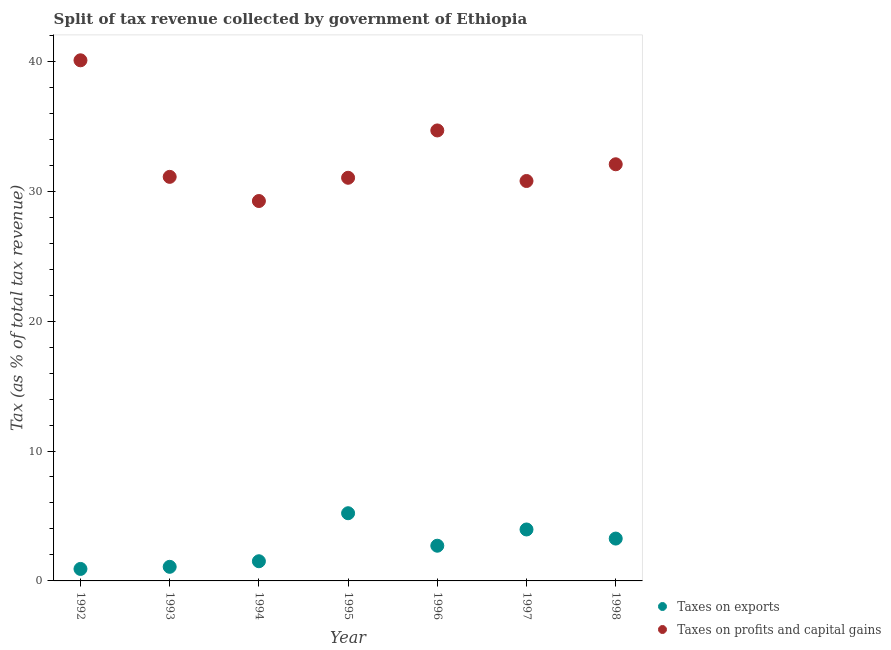What is the percentage of revenue obtained from taxes on exports in 1992?
Offer a very short reply. 0.92. Across all years, what is the maximum percentage of revenue obtained from taxes on profits and capital gains?
Your response must be concise. 40.07. Across all years, what is the minimum percentage of revenue obtained from taxes on exports?
Give a very brief answer. 0.92. What is the total percentage of revenue obtained from taxes on profits and capital gains in the graph?
Give a very brief answer. 228.97. What is the difference between the percentage of revenue obtained from taxes on exports in 1996 and that in 1998?
Offer a terse response. -0.55. What is the difference between the percentage of revenue obtained from taxes on exports in 1997 and the percentage of revenue obtained from taxes on profits and capital gains in 1995?
Your answer should be very brief. -27.07. What is the average percentage of revenue obtained from taxes on exports per year?
Make the answer very short. 2.67. In the year 1998, what is the difference between the percentage of revenue obtained from taxes on exports and percentage of revenue obtained from taxes on profits and capital gains?
Ensure brevity in your answer.  -28.81. In how many years, is the percentage of revenue obtained from taxes on profits and capital gains greater than 8 %?
Offer a very short reply. 7. What is the ratio of the percentage of revenue obtained from taxes on profits and capital gains in 1993 to that in 1997?
Offer a terse response. 1.01. Is the percentage of revenue obtained from taxes on exports in 1994 less than that in 1996?
Ensure brevity in your answer.  Yes. Is the difference between the percentage of revenue obtained from taxes on profits and capital gains in 1996 and 1997 greater than the difference between the percentage of revenue obtained from taxes on exports in 1996 and 1997?
Offer a very short reply. Yes. What is the difference between the highest and the second highest percentage of revenue obtained from taxes on profits and capital gains?
Provide a succinct answer. 5.4. What is the difference between the highest and the lowest percentage of revenue obtained from taxes on profits and capital gains?
Make the answer very short. 10.83. Does the percentage of revenue obtained from taxes on profits and capital gains monotonically increase over the years?
Your response must be concise. No. What is the difference between two consecutive major ticks on the Y-axis?
Provide a succinct answer. 10. Are the values on the major ticks of Y-axis written in scientific E-notation?
Your answer should be compact. No. Where does the legend appear in the graph?
Give a very brief answer. Bottom right. How are the legend labels stacked?
Your answer should be very brief. Vertical. What is the title of the graph?
Your answer should be very brief. Split of tax revenue collected by government of Ethiopia. What is the label or title of the X-axis?
Give a very brief answer. Year. What is the label or title of the Y-axis?
Your answer should be very brief. Tax (as % of total tax revenue). What is the Tax (as % of total tax revenue) in Taxes on exports in 1992?
Keep it short and to the point. 0.92. What is the Tax (as % of total tax revenue) of Taxes on profits and capital gains in 1992?
Offer a very short reply. 40.07. What is the Tax (as % of total tax revenue) of Taxes on exports in 1993?
Offer a very short reply. 1.09. What is the Tax (as % of total tax revenue) in Taxes on profits and capital gains in 1993?
Offer a very short reply. 31.1. What is the Tax (as % of total tax revenue) in Taxes on exports in 1994?
Provide a short and direct response. 1.51. What is the Tax (as % of total tax revenue) in Taxes on profits and capital gains in 1994?
Your answer should be compact. 29.24. What is the Tax (as % of total tax revenue) in Taxes on exports in 1995?
Your response must be concise. 5.21. What is the Tax (as % of total tax revenue) in Taxes on profits and capital gains in 1995?
Provide a short and direct response. 31.03. What is the Tax (as % of total tax revenue) of Taxes on exports in 1996?
Keep it short and to the point. 2.71. What is the Tax (as % of total tax revenue) of Taxes on profits and capital gains in 1996?
Provide a short and direct response. 34.67. What is the Tax (as % of total tax revenue) in Taxes on exports in 1997?
Your response must be concise. 3.96. What is the Tax (as % of total tax revenue) of Taxes on profits and capital gains in 1997?
Provide a succinct answer. 30.78. What is the Tax (as % of total tax revenue) of Taxes on exports in 1998?
Offer a very short reply. 3.26. What is the Tax (as % of total tax revenue) in Taxes on profits and capital gains in 1998?
Give a very brief answer. 32.07. Across all years, what is the maximum Tax (as % of total tax revenue) in Taxes on exports?
Your response must be concise. 5.21. Across all years, what is the maximum Tax (as % of total tax revenue) in Taxes on profits and capital gains?
Your answer should be compact. 40.07. Across all years, what is the minimum Tax (as % of total tax revenue) of Taxes on exports?
Ensure brevity in your answer.  0.92. Across all years, what is the minimum Tax (as % of total tax revenue) of Taxes on profits and capital gains?
Offer a very short reply. 29.24. What is the total Tax (as % of total tax revenue) in Taxes on exports in the graph?
Your response must be concise. 18.66. What is the total Tax (as % of total tax revenue) of Taxes on profits and capital gains in the graph?
Give a very brief answer. 228.97. What is the difference between the Tax (as % of total tax revenue) of Taxes on exports in 1992 and that in 1993?
Provide a short and direct response. -0.16. What is the difference between the Tax (as % of total tax revenue) in Taxes on profits and capital gains in 1992 and that in 1993?
Provide a short and direct response. 8.97. What is the difference between the Tax (as % of total tax revenue) of Taxes on exports in 1992 and that in 1994?
Your answer should be compact. -0.59. What is the difference between the Tax (as % of total tax revenue) of Taxes on profits and capital gains in 1992 and that in 1994?
Ensure brevity in your answer.  10.83. What is the difference between the Tax (as % of total tax revenue) in Taxes on exports in 1992 and that in 1995?
Give a very brief answer. -4.29. What is the difference between the Tax (as % of total tax revenue) in Taxes on profits and capital gains in 1992 and that in 1995?
Give a very brief answer. 9.04. What is the difference between the Tax (as % of total tax revenue) in Taxes on exports in 1992 and that in 1996?
Provide a short and direct response. -1.79. What is the difference between the Tax (as % of total tax revenue) in Taxes on profits and capital gains in 1992 and that in 1996?
Your response must be concise. 5.4. What is the difference between the Tax (as % of total tax revenue) in Taxes on exports in 1992 and that in 1997?
Offer a very short reply. -3.04. What is the difference between the Tax (as % of total tax revenue) of Taxes on profits and capital gains in 1992 and that in 1997?
Ensure brevity in your answer.  9.29. What is the difference between the Tax (as % of total tax revenue) of Taxes on exports in 1992 and that in 1998?
Your answer should be compact. -2.34. What is the difference between the Tax (as % of total tax revenue) of Taxes on profits and capital gains in 1992 and that in 1998?
Your answer should be compact. 8. What is the difference between the Tax (as % of total tax revenue) of Taxes on exports in 1993 and that in 1994?
Make the answer very short. -0.43. What is the difference between the Tax (as % of total tax revenue) of Taxes on profits and capital gains in 1993 and that in 1994?
Give a very brief answer. 1.86. What is the difference between the Tax (as % of total tax revenue) of Taxes on exports in 1993 and that in 1995?
Your answer should be compact. -4.13. What is the difference between the Tax (as % of total tax revenue) in Taxes on profits and capital gains in 1993 and that in 1995?
Keep it short and to the point. 0.07. What is the difference between the Tax (as % of total tax revenue) in Taxes on exports in 1993 and that in 1996?
Provide a short and direct response. -1.62. What is the difference between the Tax (as % of total tax revenue) in Taxes on profits and capital gains in 1993 and that in 1996?
Ensure brevity in your answer.  -3.57. What is the difference between the Tax (as % of total tax revenue) in Taxes on exports in 1993 and that in 1997?
Make the answer very short. -2.88. What is the difference between the Tax (as % of total tax revenue) of Taxes on profits and capital gains in 1993 and that in 1997?
Give a very brief answer. 0.32. What is the difference between the Tax (as % of total tax revenue) in Taxes on exports in 1993 and that in 1998?
Your response must be concise. -2.17. What is the difference between the Tax (as % of total tax revenue) of Taxes on profits and capital gains in 1993 and that in 1998?
Offer a very short reply. -0.97. What is the difference between the Tax (as % of total tax revenue) of Taxes on exports in 1994 and that in 1995?
Offer a very short reply. -3.7. What is the difference between the Tax (as % of total tax revenue) in Taxes on profits and capital gains in 1994 and that in 1995?
Your response must be concise. -1.79. What is the difference between the Tax (as % of total tax revenue) in Taxes on exports in 1994 and that in 1996?
Keep it short and to the point. -1.19. What is the difference between the Tax (as % of total tax revenue) of Taxes on profits and capital gains in 1994 and that in 1996?
Offer a terse response. -5.43. What is the difference between the Tax (as % of total tax revenue) of Taxes on exports in 1994 and that in 1997?
Keep it short and to the point. -2.45. What is the difference between the Tax (as % of total tax revenue) in Taxes on profits and capital gains in 1994 and that in 1997?
Provide a short and direct response. -1.54. What is the difference between the Tax (as % of total tax revenue) of Taxes on exports in 1994 and that in 1998?
Provide a succinct answer. -1.74. What is the difference between the Tax (as % of total tax revenue) in Taxes on profits and capital gains in 1994 and that in 1998?
Ensure brevity in your answer.  -2.83. What is the difference between the Tax (as % of total tax revenue) of Taxes on exports in 1995 and that in 1996?
Your answer should be very brief. 2.5. What is the difference between the Tax (as % of total tax revenue) of Taxes on profits and capital gains in 1995 and that in 1996?
Provide a short and direct response. -3.64. What is the difference between the Tax (as % of total tax revenue) of Taxes on exports in 1995 and that in 1997?
Give a very brief answer. 1.25. What is the difference between the Tax (as % of total tax revenue) in Taxes on profits and capital gains in 1995 and that in 1997?
Your answer should be very brief. 0.25. What is the difference between the Tax (as % of total tax revenue) of Taxes on exports in 1995 and that in 1998?
Your answer should be very brief. 1.95. What is the difference between the Tax (as % of total tax revenue) in Taxes on profits and capital gains in 1995 and that in 1998?
Give a very brief answer. -1.04. What is the difference between the Tax (as % of total tax revenue) of Taxes on exports in 1996 and that in 1997?
Make the answer very short. -1.25. What is the difference between the Tax (as % of total tax revenue) of Taxes on profits and capital gains in 1996 and that in 1997?
Offer a very short reply. 3.89. What is the difference between the Tax (as % of total tax revenue) in Taxes on exports in 1996 and that in 1998?
Offer a terse response. -0.55. What is the difference between the Tax (as % of total tax revenue) of Taxes on profits and capital gains in 1996 and that in 1998?
Your answer should be compact. 2.6. What is the difference between the Tax (as % of total tax revenue) of Taxes on exports in 1997 and that in 1998?
Your answer should be compact. 0.7. What is the difference between the Tax (as % of total tax revenue) in Taxes on profits and capital gains in 1997 and that in 1998?
Your response must be concise. -1.29. What is the difference between the Tax (as % of total tax revenue) of Taxes on exports in 1992 and the Tax (as % of total tax revenue) of Taxes on profits and capital gains in 1993?
Make the answer very short. -30.18. What is the difference between the Tax (as % of total tax revenue) of Taxes on exports in 1992 and the Tax (as % of total tax revenue) of Taxes on profits and capital gains in 1994?
Offer a very short reply. -28.32. What is the difference between the Tax (as % of total tax revenue) of Taxes on exports in 1992 and the Tax (as % of total tax revenue) of Taxes on profits and capital gains in 1995?
Your response must be concise. -30.11. What is the difference between the Tax (as % of total tax revenue) of Taxes on exports in 1992 and the Tax (as % of total tax revenue) of Taxes on profits and capital gains in 1996?
Keep it short and to the point. -33.75. What is the difference between the Tax (as % of total tax revenue) in Taxes on exports in 1992 and the Tax (as % of total tax revenue) in Taxes on profits and capital gains in 1997?
Give a very brief answer. -29.86. What is the difference between the Tax (as % of total tax revenue) of Taxes on exports in 1992 and the Tax (as % of total tax revenue) of Taxes on profits and capital gains in 1998?
Provide a succinct answer. -31.15. What is the difference between the Tax (as % of total tax revenue) of Taxes on exports in 1993 and the Tax (as % of total tax revenue) of Taxes on profits and capital gains in 1994?
Your response must be concise. -28.16. What is the difference between the Tax (as % of total tax revenue) in Taxes on exports in 1993 and the Tax (as % of total tax revenue) in Taxes on profits and capital gains in 1995?
Offer a terse response. -29.95. What is the difference between the Tax (as % of total tax revenue) in Taxes on exports in 1993 and the Tax (as % of total tax revenue) in Taxes on profits and capital gains in 1996?
Provide a succinct answer. -33.59. What is the difference between the Tax (as % of total tax revenue) in Taxes on exports in 1993 and the Tax (as % of total tax revenue) in Taxes on profits and capital gains in 1997?
Provide a succinct answer. -29.7. What is the difference between the Tax (as % of total tax revenue) in Taxes on exports in 1993 and the Tax (as % of total tax revenue) in Taxes on profits and capital gains in 1998?
Ensure brevity in your answer.  -30.98. What is the difference between the Tax (as % of total tax revenue) in Taxes on exports in 1994 and the Tax (as % of total tax revenue) in Taxes on profits and capital gains in 1995?
Your response must be concise. -29.52. What is the difference between the Tax (as % of total tax revenue) of Taxes on exports in 1994 and the Tax (as % of total tax revenue) of Taxes on profits and capital gains in 1996?
Offer a terse response. -33.16. What is the difference between the Tax (as % of total tax revenue) of Taxes on exports in 1994 and the Tax (as % of total tax revenue) of Taxes on profits and capital gains in 1997?
Keep it short and to the point. -29.27. What is the difference between the Tax (as % of total tax revenue) in Taxes on exports in 1994 and the Tax (as % of total tax revenue) in Taxes on profits and capital gains in 1998?
Provide a short and direct response. -30.55. What is the difference between the Tax (as % of total tax revenue) in Taxes on exports in 1995 and the Tax (as % of total tax revenue) in Taxes on profits and capital gains in 1996?
Provide a short and direct response. -29.46. What is the difference between the Tax (as % of total tax revenue) of Taxes on exports in 1995 and the Tax (as % of total tax revenue) of Taxes on profits and capital gains in 1997?
Give a very brief answer. -25.57. What is the difference between the Tax (as % of total tax revenue) in Taxes on exports in 1995 and the Tax (as % of total tax revenue) in Taxes on profits and capital gains in 1998?
Keep it short and to the point. -26.86. What is the difference between the Tax (as % of total tax revenue) in Taxes on exports in 1996 and the Tax (as % of total tax revenue) in Taxes on profits and capital gains in 1997?
Your answer should be compact. -28.07. What is the difference between the Tax (as % of total tax revenue) in Taxes on exports in 1996 and the Tax (as % of total tax revenue) in Taxes on profits and capital gains in 1998?
Give a very brief answer. -29.36. What is the difference between the Tax (as % of total tax revenue) in Taxes on exports in 1997 and the Tax (as % of total tax revenue) in Taxes on profits and capital gains in 1998?
Make the answer very short. -28.11. What is the average Tax (as % of total tax revenue) of Taxes on exports per year?
Provide a succinct answer. 2.67. What is the average Tax (as % of total tax revenue) of Taxes on profits and capital gains per year?
Offer a very short reply. 32.71. In the year 1992, what is the difference between the Tax (as % of total tax revenue) in Taxes on exports and Tax (as % of total tax revenue) in Taxes on profits and capital gains?
Ensure brevity in your answer.  -39.15. In the year 1993, what is the difference between the Tax (as % of total tax revenue) in Taxes on exports and Tax (as % of total tax revenue) in Taxes on profits and capital gains?
Give a very brief answer. -30.02. In the year 1994, what is the difference between the Tax (as % of total tax revenue) of Taxes on exports and Tax (as % of total tax revenue) of Taxes on profits and capital gains?
Ensure brevity in your answer.  -27.73. In the year 1995, what is the difference between the Tax (as % of total tax revenue) in Taxes on exports and Tax (as % of total tax revenue) in Taxes on profits and capital gains?
Your answer should be compact. -25.82. In the year 1996, what is the difference between the Tax (as % of total tax revenue) of Taxes on exports and Tax (as % of total tax revenue) of Taxes on profits and capital gains?
Make the answer very short. -31.96. In the year 1997, what is the difference between the Tax (as % of total tax revenue) of Taxes on exports and Tax (as % of total tax revenue) of Taxes on profits and capital gains?
Offer a very short reply. -26.82. In the year 1998, what is the difference between the Tax (as % of total tax revenue) of Taxes on exports and Tax (as % of total tax revenue) of Taxes on profits and capital gains?
Make the answer very short. -28.81. What is the ratio of the Tax (as % of total tax revenue) in Taxes on exports in 1992 to that in 1993?
Give a very brief answer. 0.85. What is the ratio of the Tax (as % of total tax revenue) in Taxes on profits and capital gains in 1992 to that in 1993?
Make the answer very short. 1.29. What is the ratio of the Tax (as % of total tax revenue) of Taxes on exports in 1992 to that in 1994?
Provide a short and direct response. 0.61. What is the ratio of the Tax (as % of total tax revenue) of Taxes on profits and capital gains in 1992 to that in 1994?
Provide a short and direct response. 1.37. What is the ratio of the Tax (as % of total tax revenue) of Taxes on exports in 1992 to that in 1995?
Your answer should be very brief. 0.18. What is the ratio of the Tax (as % of total tax revenue) in Taxes on profits and capital gains in 1992 to that in 1995?
Provide a succinct answer. 1.29. What is the ratio of the Tax (as % of total tax revenue) of Taxes on exports in 1992 to that in 1996?
Your answer should be very brief. 0.34. What is the ratio of the Tax (as % of total tax revenue) of Taxes on profits and capital gains in 1992 to that in 1996?
Provide a short and direct response. 1.16. What is the ratio of the Tax (as % of total tax revenue) in Taxes on exports in 1992 to that in 1997?
Provide a succinct answer. 0.23. What is the ratio of the Tax (as % of total tax revenue) in Taxes on profits and capital gains in 1992 to that in 1997?
Make the answer very short. 1.3. What is the ratio of the Tax (as % of total tax revenue) in Taxes on exports in 1992 to that in 1998?
Your answer should be very brief. 0.28. What is the ratio of the Tax (as % of total tax revenue) of Taxes on profits and capital gains in 1992 to that in 1998?
Your answer should be very brief. 1.25. What is the ratio of the Tax (as % of total tax revenue) of Taxes on exports in 1993 to that in 1994?
Provide a short and direct response. 0.72. What is the ratio of the Tax (as % of total tax revenue) of Taxes on profits and capital gains in 1993 to that in 1994?
Offer a terse response. 1.06. What is the ratio of the Tax (as % of total tax revenue) in Taxes on exports in 1993 to that in 1995?
Make the answer very short. 0.21. What is the ratio of the Tax (as % of total tax revenue) in Taxes on exports in 1993 to that in 1996?
Provide a short and direct response. 0.4. What is the ratio of the Tax (as % of total tax revenue) in Taxes on profits and capital gains in 1993 to that in 1996?
Keep it short and to the point. 0.9. What is the ratio of the Tax (as % of total tax revenue) of Taxes on exports in 1993 to that in 1997?
Make the answer very short. 0.27. What is the ratio of the Tax (as % of total tax revenue) of Taxes on profits and capital gains in 1993 to that in 1997?
Your answer should be very brief. 1.01. What is the ratio of the Tax (as % of total tax revenue) of Taxes on exports in 1993 to that in 1998?
Offer a terse response. 0.33. What is the ratio of the Tax (as % of total tax revenue) in Taxes on profits and capital gains in 1993 to that in 1998?
Ensure brevity in your answer.  0.97. What is the ratio of the Tax (as % of total tax revenue) in Taxes on exports in 1994 to that in 1995?
Keep it short and to the point. 0.29. What is the ratio of the Tax (as % of total tax revenue) of Taxes on profits and capital gains in 1994 to that in 1995?
Keep it short and to the point. 0.94. What is the ratio of the Tax (as % of total tax revenue) in Taxes on exports in 1994 to that in 1996?
Your answer should be compact. 0.56. What is the ratio of the Tax (as % of total tax revenue) in Taxes on profits and capital gains in 1994 to that in 1996?
Offer a terse response. 0.84. What is the ratio of the Tax (as % of total tax revenue) in Taxes on exports in 1994 to that in 1997?
Keep it short and to the point. 0.38. What is the ratio of the Tax (as % of total tax revenue) of Taxes on profits and capital gains in 1994 to that in 1997?
Make the answer very short. 0.95. What is the ratio of the Tax (as % of total tax revenue) in Taxes on exports in 1994 to that in 1998?
Your answer should be very brief. 0.46. What is the ratio of the Tax (as % of total tax revenue) in Taxes on profits and capital gains in 1994 to that in 1998?
Offer a terse response. 0.91. What is the ratio of the Tax (as % of total tax revenue) of Taxes on exports in 1995 to that in 1996?
Provide a succinct answer. 1.92. What is the ratio of the Tax (as % of total tax revenue) of Taxes on profits and capital gains in 1995 to that in 1996?
Offer a very short reply. 0.9. What is the ratio of the Tax (as % of total tax revenue) of Taxes on exports in 1995 to that in 1997?
Offer a very short reply. 1.32. What is the ratio of the Tax (as % of total tax revenue) in Taxes on exports in 1995 to that in 1998?
Your answer should be compact. 1.6. What is the ratio of the Tax (as % of total tax revenue) in Taxes on profits and capital gains in 1995 to that in 1998?
Ensure brevity in your answer.  0.97. What is the ratio of the Tax (as % of total tax revenue) of Taxes on exports in 1996 to that in 1997?
Offer a terse response. 0.68. What is the ratio of the Tax (as % of total tax revenue) in Taxes on profits and capital gains in 1996 to that in 1997?
Offer a terse response. 1.13. What is the ratio of the Tax (as % of total tax revenue) of Taxes on exports in 1996 to that in 1998?
Your answer should be compact. 0.83. What is the ratio of the Tax (as % of total tax revenue) in Taxes on profits and capital gains in 1996 to that in 1998?
Your answer should be compact. 1.08. What is the ratio of the Tax (as % of total tax revenue) of Taxes on exports in 1997 to that in 1998?
Provide a succinct answer. 1.22. What is the ratio of the Tax (as % of total tax revenue) in Taxes on profits and capital gains in 1997 to that in 1998?
Provide a succinct answer. 0.96. What is the difference between the highest and the second highest Tax (as % of total tax revenue) of Taxes on exports?
Your answer should be very brief. 1.25. What is the difference between the highest and the second highest Tax (as % of total tax revenue) of Taxes on profits and capital gains?
Your answer should be compact. 5.4. What is the difference between the highest and the lowest Tax (as % of total tax revenue) in Taxes on exports?
Keep it short and to the point. 4.29. What is the difference between the highest and the lowest Tax (as % of total tax revenue) of Taxes on profits and capital gains?
Offer a very short reply. 10.83. 